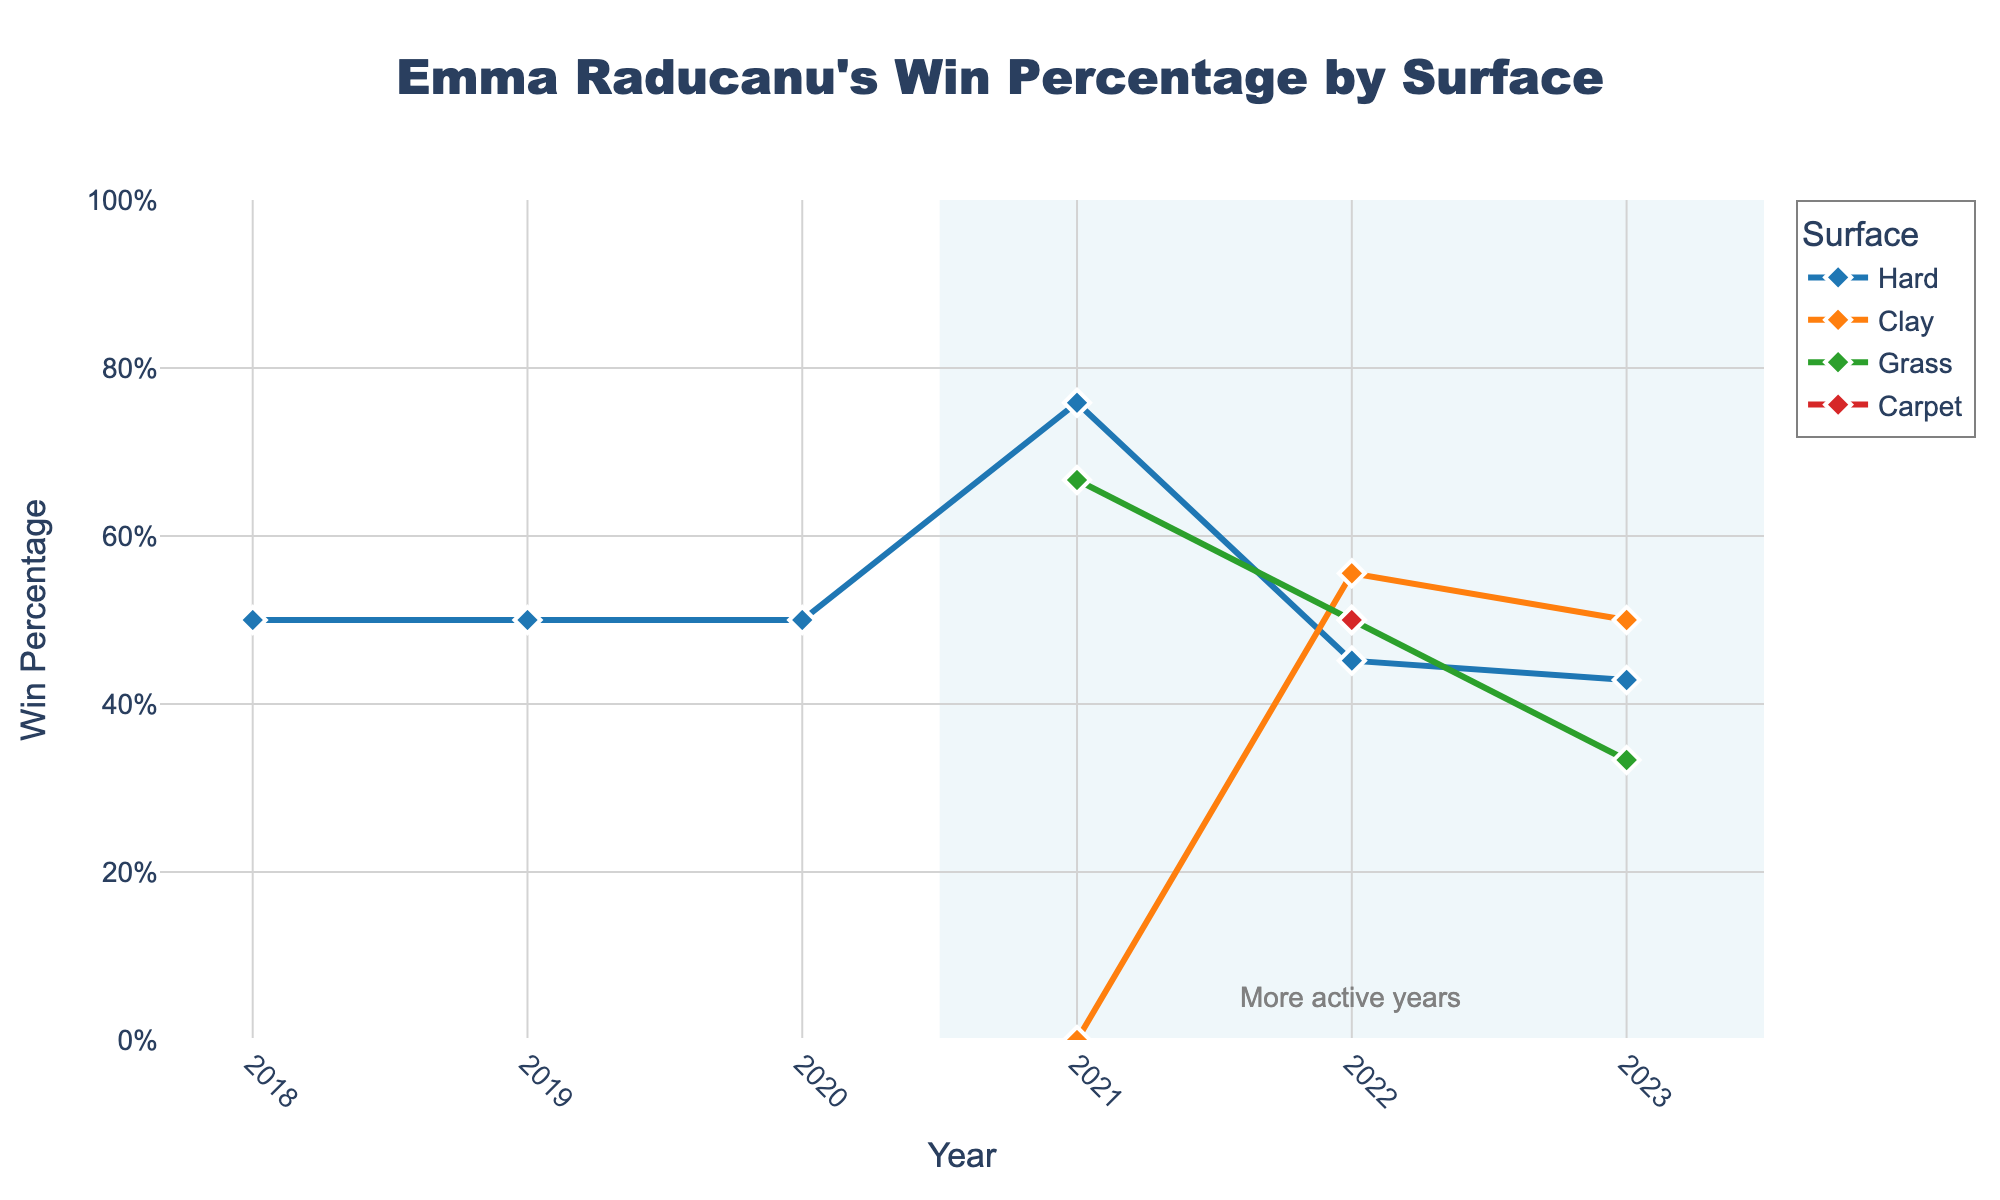What was Emma Raducanu's highest win percentage on any surface in 2021? In 2021, look at each surface; Hard: (22 wins / (22 wins + 7 losses)) * 100 = 75.9%, Clay: (0 wins / (0 wins + 1 loss)) * 100 = 0%, Grass: (4 wins / (4 wins + 2 losses)) * 100 = 66.7%. The highest win percentage was on Hard at 75.9%.
Answer: 75.9% Which surface had the lowest win percentage in 2022? In 2022, compare the win percentages for each surface; Hard: (14 wins / (14 wins + 17 losses)) * 100 = 45.2%, Clay: (5 wins / (5 wins + 4 losses)) * 100 = 55.6%, Grass: (2 wins / (2 wins + 2 losses)) * 100 = 50%, Carpet: (1 win / (1 win + 1 loss)) * 100 = 50%. The lowest win percentage was on Hard at 45.2%.
Answer: Hard Between 2021 and 2022, on which surface did Emma Raducanu's win percentage decrease the most? Calculate the difference in win percentage between 2021 and 2022 for each surface; Hard: 75.9% - 45.2% = 30.7%, Clay: 0% - 55.6% = -55.6% (increase), Grass: 66.7% - 50% = 16.7%. The largest decrease was on Hard at 30.7%.
Answer: Hard What trend in win percentage can be observed for Raducanu on Hard courts from 2018 to 2023? Observe the win percentages for Hard courts over the years; 2018: 50%, 2019: 50%, 2020: 50%, 2021: 75.9%, 2022: 45.2%, 2023: 42.9%. There's a significant increase from 2020 to 2021, and then a steady decrease through 2022 and 2023.
Answer: Increase then decrease Which year had the highest overall win percentage across all surfaces? Calculate the total win percentage for each year by adding the year's win percentages for all surfaces; 
2021: (75.9% + 0% + 66.7%) / 3 = 47.5%, 
2022: (45.2% + 55.6% + 50% + 50%) / 4 = 50.2%, 
2023: (42.9% + 50% + 33.3%) / 3 = 42.1%. 2022 has the highest overall win percentage.
Answer: 2022 In which year did Raducanu play the most matches on Hard surfaces, and how does this relate to her win percentage that year? Count the total matches each year on Hard surfaces and correlate with win percentage; 
2018: 2 matches, 50% win,
2019: 4 matches, 50% win,
2020: 2 matches, 50% win,
2021: 29 matches, 75.9% win,
2022: 31 matches, 45.2% win,
2023: 14 matches, 42.9% win.
The most matches were in 2022, but her win percentage was lower compared to 2021.
Answer: 2022, lower percentage How did the win percentage on Grass surfaces change from 2021 to 2023? Look at the win percentages for Grass from 2021 to 2023; 2021: 66.7%, 2022: 50%, 2023: 33.3%. There was a consistent decline each year.
Answer: Declined 